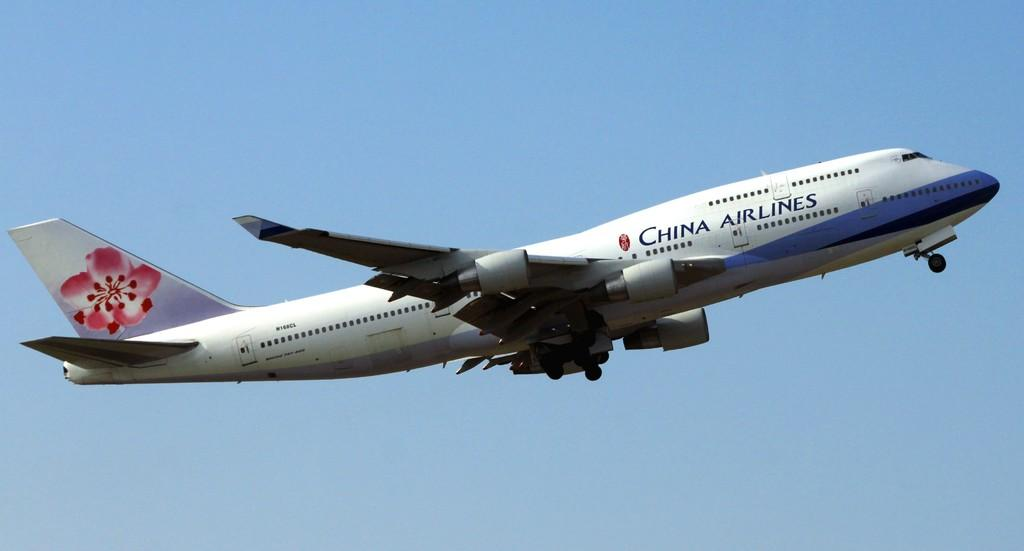<image>
Provide a brief description of the given image. A China airlines passenger jet is taking off into the air. 